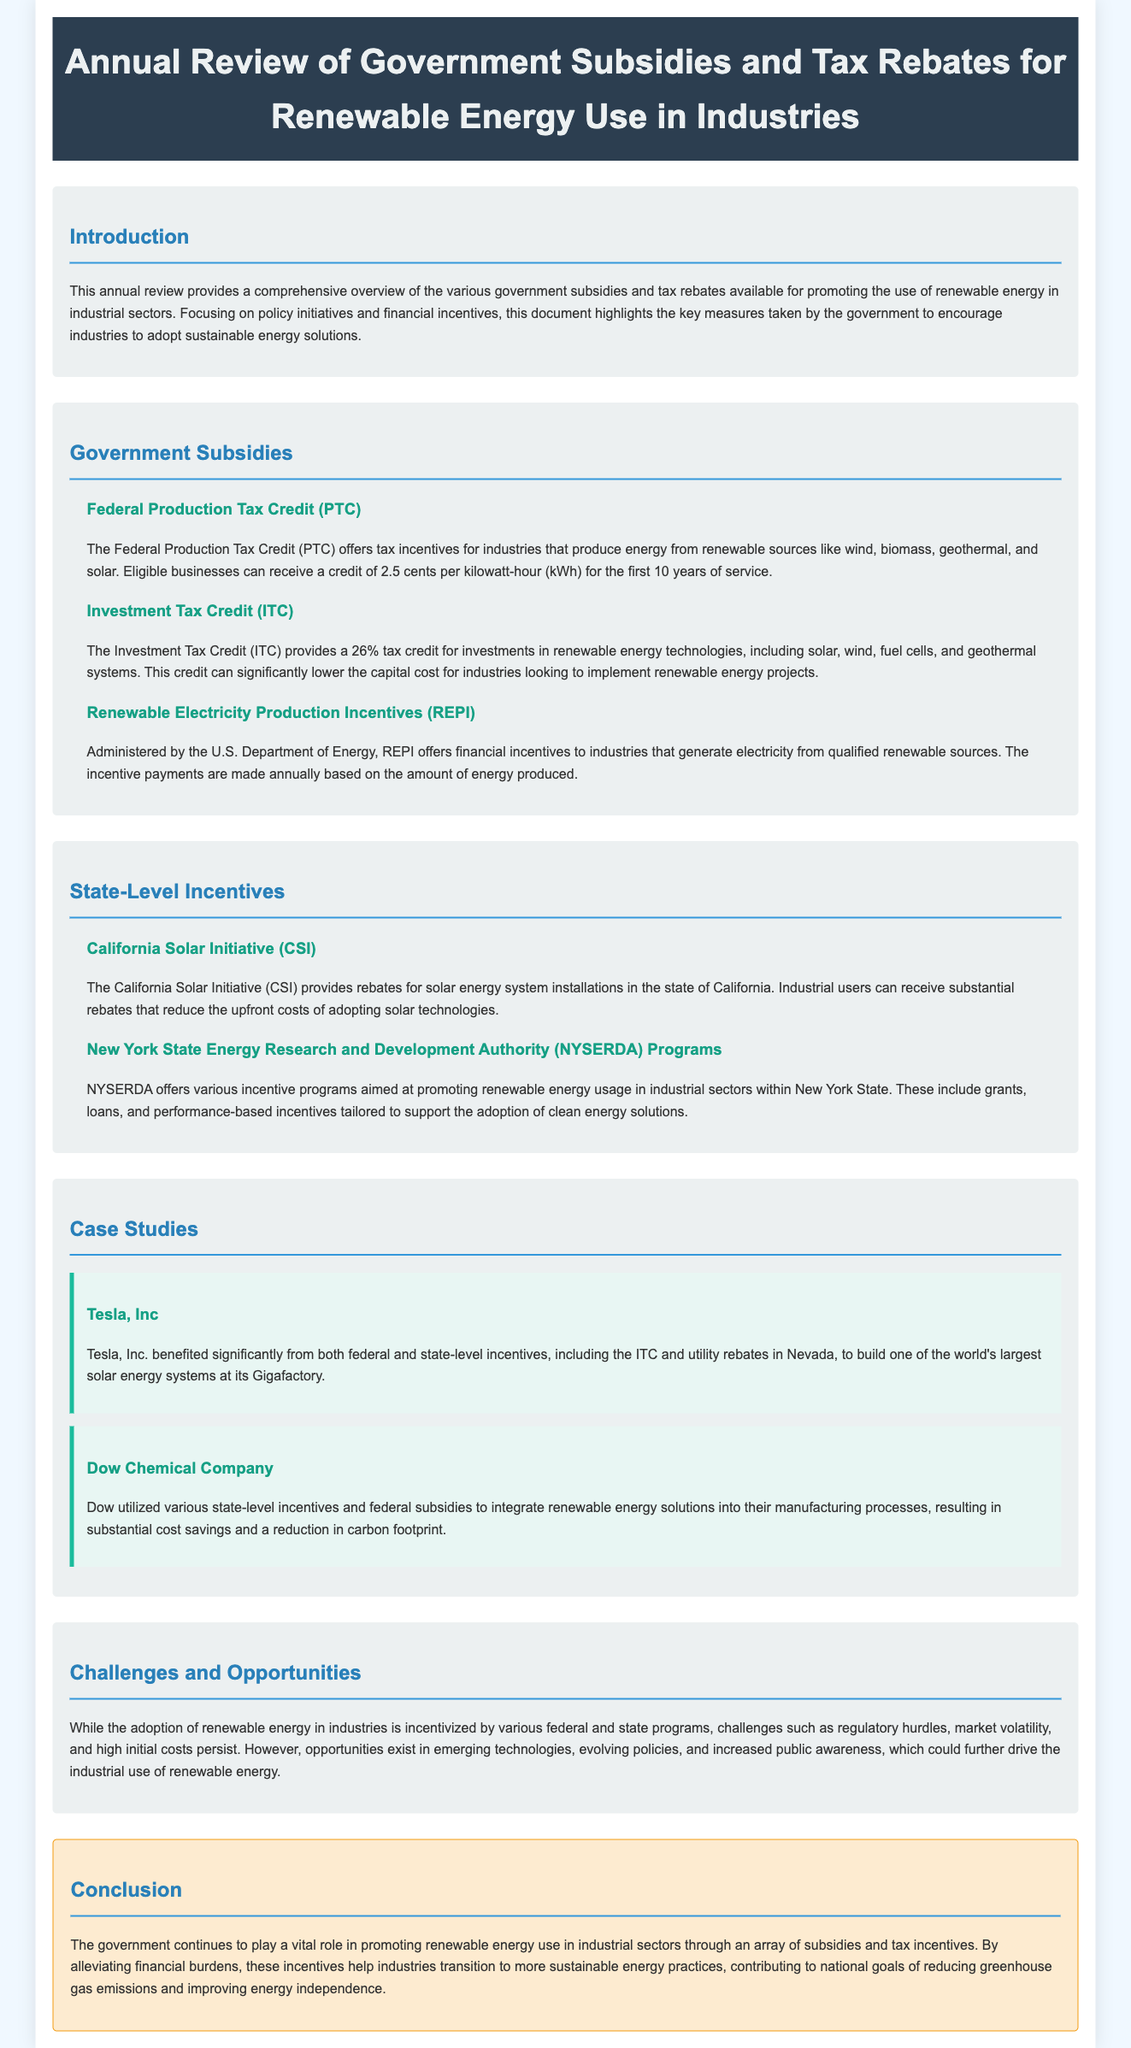What is the title of the document? The title is given in the header section of the document, which is ‘Annual Review of Government Subsidies and Tax Rebates for Renewable Energy Use in Industries’.
Answer: Annual Review of Government Subsidies and Tax Rebates for Renewable Energy Use in Industries What does the ITC provide? The ITC provides a tax credit that is described in the subsection about it; specifically, a 26% tax credit for renewable energy technologies.
Answer: 26% tax credit What does the Federal Production Tax Credit (PTC) offer? The PTC offers tax incentives for industries that produce energy from renewable sources, providing a credit of 2.5 cents per kilowatt-hour.
Answer: 2.5 cents per kilowatt-hour What is a challenge for industries adopting renewable energy? The document lists challenges faced by industries, mentioning regulatory hurdles among them.
Answer: Regulatory hurdles Which company benefited from both federal and state-level incentives? The document mentions Tesla, Inc. as a company that benefited from both federal and state-level incentives.
Answer: Tesla, Inc What type of incentives does NYSERDA offer? The document specifies that NYSERDA offers incentive programs including grants, loans, and performance-based incentives.
Answer: Grants, loans, and performance-based incentives What does the conclusion state about the government's role? The conclusion emphasizes the government’s vital role in promoting renewable energy through subsidies and tax incentives.
Answer: Vital role How does Dow Chemical Company use incentives? Dow Chemical Company utilized various incentives to integrate renewable energy solutions, resulting in cost savings and carbon footprint reduction.
Answer: Cost savings and carbon footprint reduction 